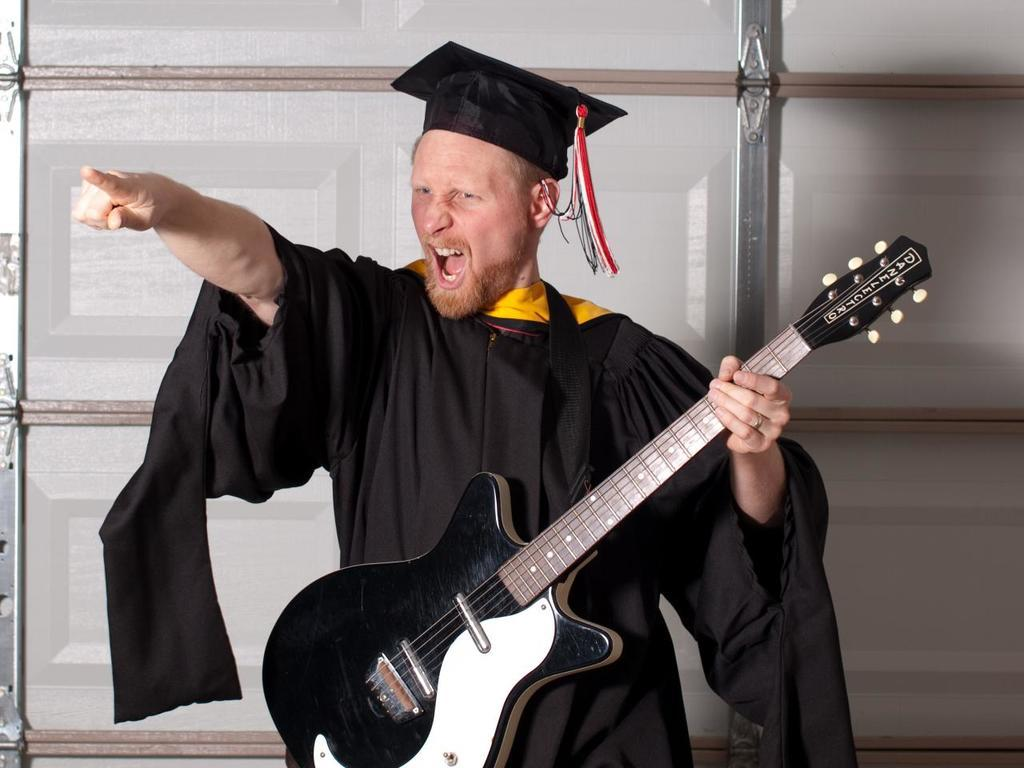What is the main subject of the picture? The main subject of the picture is a person. Can you describe the person's appearance in the image? The person is wearing a black costume. What is the person holding in the image? The person is holding a guitar. What type of farm animals can be seen in the background of the image? There are no farm animals present in the image; it features a person wearing a black costume and holding a guitar. 